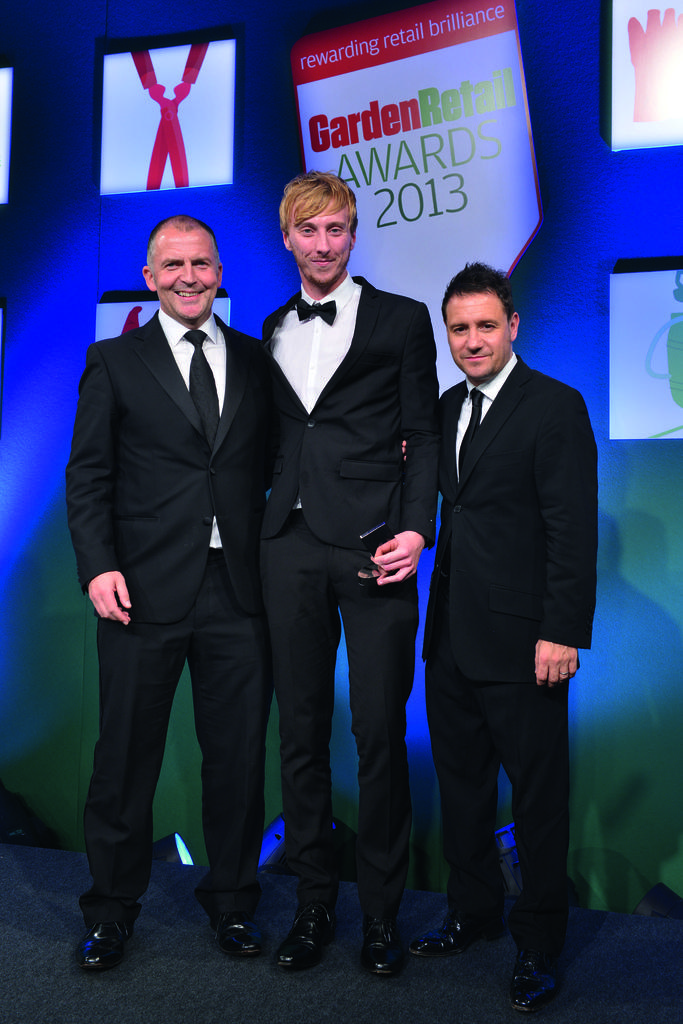How many people are in the image? There are persons standing in the image. What is the facial expression of the persons in the image? The persons are smiling. What can be seen in the background of the image? There is a banner in the background of the image. What is written on the banner? There is text written on the banner. What type of texture can be seen on the houses in the image? There are no houses present in the image; it only features persons standing and a banner in the background. 